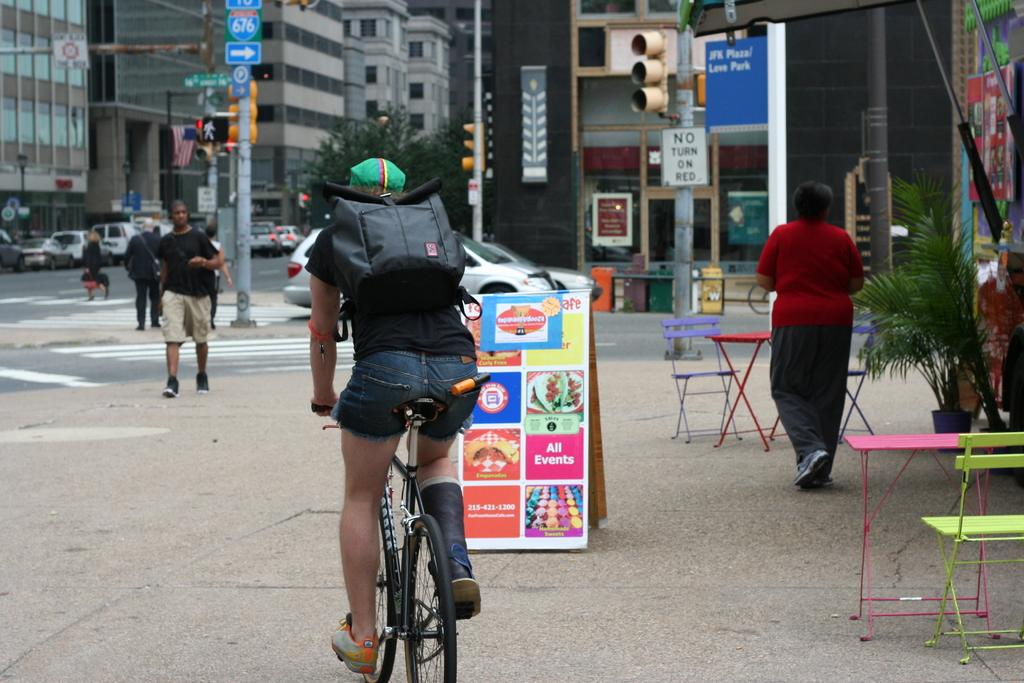What is the main subject of the image? The main subject of the image is a person riding a bicycle. What is the person wearing on their back? The person is wearing a black bag on their back. What is in front of the bicyclist? There is a group of people, cars, and a building in front of the bicyclist. Can you see a hole in the road that the bicyclist is riding over? There is no hole visible in the road in the image. What type of banana is the person riding the bicycle holding? There is no banana present in the image. 